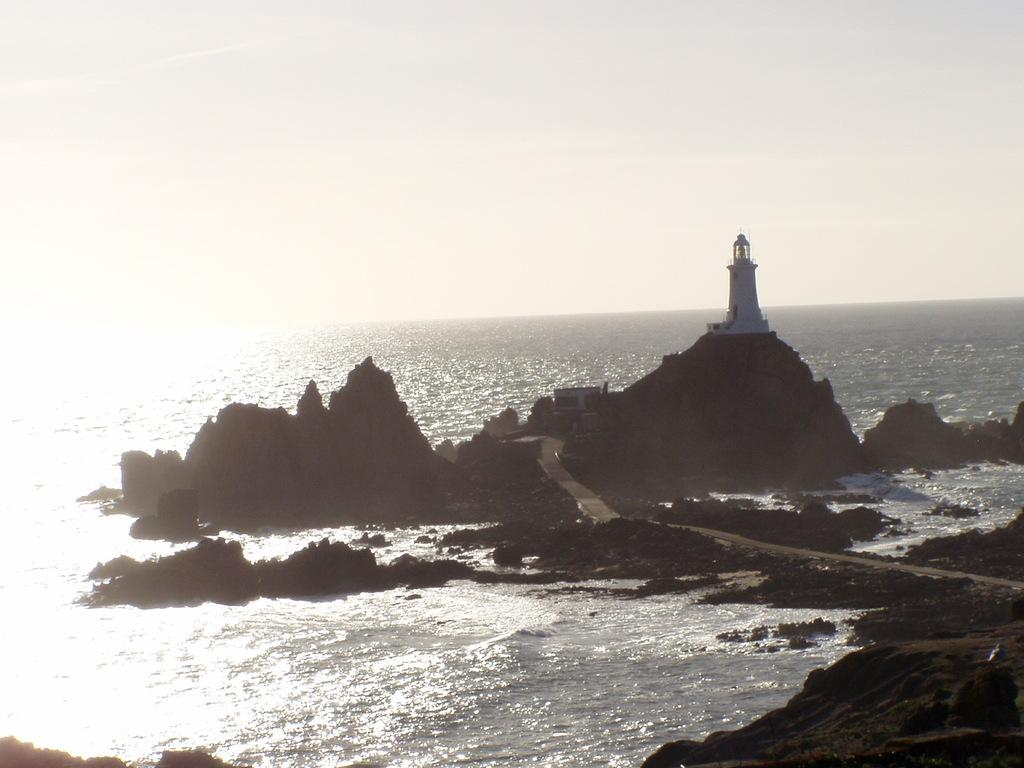What structure can be seen on the hill in the image? There is a lighthouse on a hill in the image. What type of terrain is visible in the image? There are rock hills in the image. What body of water is visible in the image? There is an ocean visible in the image. What is the condition of the sky in the image? The sky is clear in the image. What musical instrument can be heard playing in the image? There is no musical instrument present in the image, and therefore no sound can be heard. 